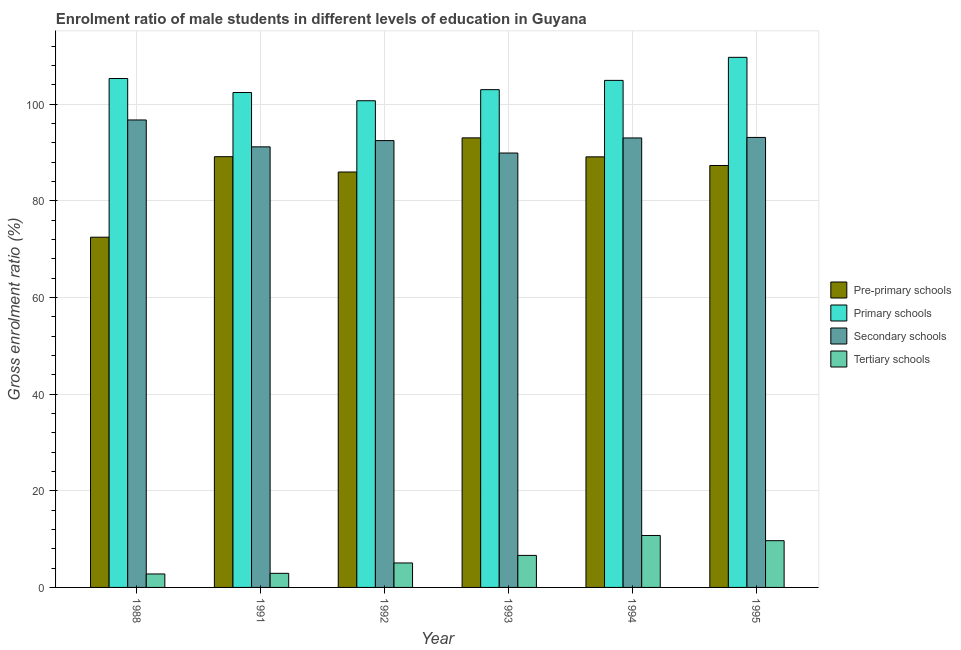How many different coloured bars are there?
Your answer should be compact. 4. How many groups of bars are there?
Offer a very short reply. 6. Are the number of bars on each tick of the X-axis equal?
Your answer should be very brief. Yes. How many bars are there on the 5th tick from the left?
Your answer should be compact. 4. What is the gross enrolment ratio(female) in primary schools in 1992?
Make the answer very short. 100.68. Across all years, what is the maximum gross enrolment ratio(female) in tertiary schools?
Provide a succinct answer. 10.75. Across all years, what is the minimum gross enrolment ratio(female) in primary schools?
Provide a succinct answer. 100.68. In which year was the gross enrolment ratio(female) in secondary schools maximum?
Make the answer very short. 1988. What is the total gross enrolment ratio(female) in primary schools in the graph?
Offer a terse response. 625.89. What is the difference between the gross enrolment ratio(female) in tertiary schools in 1991 and that in 1993?
Give a very brief answer. -3.71. What is the difference between the gross enrolment ratio(female) in primary schools in 1994 and the gross enrolment ratio(female) in pre-primary schools in 1988?
Offer a terse response. -0.39. What is the average gross enrolment ratio(female) in primary schools per year?
Offer a terse response. 104.32. In the year 1991, what is the difference between the gross enrolment ratio(female) in primary schools and gross enrolment ratio(female) in tertiary schools?
Provide a short and direct response. 0. In how many years, is the gross enrolment ratio(female) in primary schools greater than 36 %?
Your answer should be very brief. 6. What is the ratio of the gross enrolment ratio(female) in pre-primary schools in 1988 to that in 1993?
Ensure brevity in your answer.  0.78. Is the gross enrolment ratio(female) in tertiary schools in 1988 less than that in 1991?
Your answer should be very brief. Yes. Is the difference between the gross enrolment ratio(female) in primary schools in 1988 and 1991 greater than the difference between the gross enrolment ratio(female) in tertiary schools in 1988 and 1991?
Make the answer very short. No. What is the difference between the highest and the second highest gross enrolment ratio(female) in pre-primary schools?
Offer a terse response. 3.89. What is the difference between the highest and the lowest gross enrolment ratio(female) in tertiary schools?
Provide a succinct answer. 7.96. What does the 3rd bar from the left in 1991 represents?
Give a very brief answer. Secondary schools. What does the 2nd bar from the right in 1993 represents?
Offer a terse response. Secondary schools. Is it the case that in every year, the sum of the gross enrolment ratio(female) in pre-primary schools and gross enrolment ratio(female) in primary schools is greater than the gross enrolment ratio(female) in secondary schools?
Provide a short and direct response. Yes. Are all the bars in the graph horizontal?
Give a very brief answer. No. Does the graph contain any zero values?
Offer a very short reply. No. Where does the legend appear in the graph?
Your response must be concise. Center right. What is the title of the graph?
Make the answer very short. Enrolment ratio of male students in different levels of education in Guyana. Does "Tracking ability" appear as one of the legend labels in the graph?
Offer a terse response. No. What is the Gross enrolment ratio (%) of Pre-primary schools in 1988?
Your answer should be very brief. 72.46. What is the Gross enrolment ratio (%) of Primary schools in 1988?
Your answer should be compact. 105.28. What is the Gross enrolment ratio (%) of Secondary schools in 1988?
Provide a short and direct response. 96.71. What is the Gross enrolment ratio (%) of Tertiary schools in 1988?
Your answer should be very brief. 2.79. What is the Gross enrolment ratio (%) in Pre-primary schools in 1991?
Make the answer very short. 89.11. What is the Gross enrolment ratio (%) in Primary schools in 1991?
Keep it short and to the point. 102.39. What is the Gross enrolment ratio (%) of Secondary schools in 1991?
Give a very brief answer. 91.15. What is the Gross enrolment ratio (%) in Tertiary schools in 1991?
Offer a very short reply. 2.91. What is the Gross enrolment ratio (%) in Pre-primary schools in 1992?
Your answer should be very brief. 85.94. What is the Gross enrolment ratio (%) of Primary schools in 1992?
Ensure brevity in your answer.  100.68. What is the Gross enrolment ratio (%) in Secondary schools in 1992?
Offer a very short reply. 92.44. What is the Gross enrolment ratio (%) of Tertiary schools in 1992?
Ensure brevity in your answer.  5.06. What is the Gross enrolment ratio (%) of Pre-primary schools in 1993?
Provide a short and direct response. 93. What is the Gross enrolment ratio (%) in Primary schools in 1993?
Give a very brief answer. 102.97. What is the Gross enrolment ratio (%) in Secondary schools in 1993?
Your answer should be very brief. 89.87. What is the Gross enrolment ratio (%) of Tertiary schools in 1993?
Offer a terse response. 6.63. What is the Gross enrolment ratio (%) of Pre-primary schools in 1994?
Offer a terse response. 89.08. What is the Gross enrolment ratio (%) in Primary schools in 1994?
Your answer should be compact. 104.9. What is the Gross enrolment ratio (%) in Secondary schools in 1994?
Keep it short and to the point. 92.99. What is the Gross enrolment ratio (%) in Tertiary schools in 1994?
Your answer should be compact. 10.75. What is the Gross enrolment ratio (%) of Pre-primary schools in 1995?
Your response must be concise. 87.29. What is the Gross enrolment ratio (%) in Primary schools in 1995?
Your answer should be very brief. 109.66. What is the Gross enrolment ratio (%) in Secondary schools in 1995?
Your response must be concise. 93.09. What is the Gross enrolment ratio (%) in Tertiary schools in 1995?
Provide a short and direct response. 9.67. Across all years, what is the maximum Gross enrolment ratio (%) of Pre-primary schools?
Your answer should be compact. 93. Across all years, what is the maximum Gross enrolment ratio (%) in Primary schools?
Make the answer very short. 109.66. Across all years, what is the maximum Gross enrolment ratio (%) of Secondary schools?
Provide a short and direct response. 96.71. Across all years, what is the maximum Gross enrolment ratio (%) in Tertiary schools?
Give a very brief answer. 10.75. Across all years, what is the minimum Gross enrolment ratio (%) of Pre-primary schools?
Provide a short and direct response. 72.46. Across all years, what is the minimum Gross enrolment ratio (%) of Primary schools?
Provide a short and direct response. 100.68. Across all years, what is the minimum Gross enrolment ratio (%) in Secondary schools?
Offer a very short reply. 89.87. Across all years, what is the minimum Gross enrolment ratio (%) of Tertiary schools?
Keep it short and to the point. 2.79. What is the total Gross enrolment ratio (%) in Pre-primary schools in the graph?
Provide a succinct answer. 516.87. What is the total Gross enrolment ratio (%) of Primary schools in the graph?
Offer a terse response. 625.89. What is the total Gross enrolment ratio (%) of Secondary schools in the graph?
Offer a terse response. 556.24. What is the total Gross enrolment ratio (%) in Tertiary schools in the graph?
Offer a very short reply. 37.8. What is the difference between the Gross enrolment ratio (%) in Pre-primary schools in 1988 and that in 1991?
Your response must be concise. -16.65. What is the difference between the Gross enrolment ratio (%) in Primary schools in 1988 and that in 1991?
Your answer should be very brief. 2.89. What is the difference between the Gross enrolment ratio (%) in Secondary schools in 1988 and that in 1991?
Ensure brevity in your answer.  5.56. What is the difference between the Gross enrolment ratio (%) in Tertiary schools in 1988 and that in 1991?
Your answer should be very brief. -0.13. What is the difference between the Gross enrolment ratio (%) of Pre-primary schools in 1988 and that in 1992?
Provide a succinct answer. -13.48. What is the difference between the Gross enrolment ratio (%) in Primary schools in 1988 and that in 1992?
Give a very brief answer. 4.6. What is the difference between the Gross enrolment ratio (%) of Secondary schools in 1988 and that in 1992?
Offer a terse response. 4.27. What is the difference between the Gross enrolment ratio (%) in Tertiary schools in 1988 and that in 1992?
Your answer should be compact. -2.28. What is the difference between the Gross enrolment ratio (%) of Pre-primary schools in 1988 and that in 1993?
Offer a terse response. -20.55. What is the difference between the Gross enrolment ratio (%) of Primary schools in 1988 and that in 1993?
Your response must be concise. 2.31. What is the difference between the Gross enrolment ratio (%) in Secondary schools in 1988 and that in 1993?
Provide a short and direct response. 6.84. What is the difference between the Gross enrolment ratio (%) in Tertiary schools in 1988 and that in 1993?
Provide a succinct answer. -3.84. What is the difference between the Gross enrolment ratio (%) of Pre-primary schools in 1988 and that in 1994?
Your answer should be compact. -16.62. What is the difference between the Gross enrolment ratio (%) in Primary schools in 1988 and that in 1994?
Ensure brevity in your answer.  0.39. What is the difference between the Gross enrolment ratio (%) of Secondary schools in 1988 and that in 1994?
Give a very brief answer. 3.72. What is the difference between the Gross enrolment ratio (%) of Tertiary schools in 1988 and that in 1994?
Your response must be concise. -7.96. What is the difference between the Gross enrolment ratio (%) of Pre-primary schools in 1988 and that in 1995?
Make the answer very short. -14.83. What is the difference between the Gross enrolment ratio (%) in Primary schools in 1988 and that in 1995?
Make the answer very short. -4.38. What is the difference between the Gross enrolment ratio (%) in Secondary schools in 1988 and that in 1995?
Your response must be concise. 3.62. What is the difference between the Gross enrolment ratio (%) in Tertiary schools in 1988 and that in 1995?
Offer a terse response. -6.89. What is the difference between the Gross enrolment ratio (%) in Pre-primary schools in 1991 and that in 1992?
Give a very brief answer. 3.17. What is the difference between the Gross enrolment ratio (%) of Primary schools in 1991 and that in 1992?
Offer a terse response. 1.71. What is the difference between the Gross enrolment ratio (%) of Secondary schools in 1991 and that in 1992?
Your answer should be compact. -1.29. What is the difference between the Gross enrolment ratio (%) of Tertiary schools in 1991 and that in 1992?
Ensure brevity in your answer.  -2.15. What is the difference between the Gross enrolment ratio (%) in Pre-primary schools in 1991 and that in 1993?
Offer a very short reply. -3.89. What is the difference between the Gross enrolment ratio (%) in Primary schools in 1991 and that in 1993?
Your answer should be very brief. -0.58. What is the difference between the Gross enrolment ratio (%) in Secondary schools in 1991 and that in 1993?
Offer a terse response. 1.28. What is the difference between the Gross enrolment ratio (%) of Tertiary schools in 1991 and that in 1993?
Keep it short and to the point. -3.71. What is the difference between the Gross enrolment ratio (%) in Pre-primary schools in 1991 and that in 1994?
Your answer should be compact. 0.03. What is the difference between the Gross enrolment ratio (%) of Primary schools in 1991 and that in 1994?
Offer a terse response. -2.51. What is the difference between the Gross enrolment ratio (%) in Secondary schools in 1991 and that in 1994?
Provide a succinct answer. -1.84. What is the difference between the Gross enrolment ratio (%) in Tertiary schools in 1991 and that in 1994?
Provide a succinct answer. -7.83. What is the difference between the Gross enrolment ratio (%) in Pre-primary schools in 1991 and that in 1995?
Give a very brief answer. 1.82. What is the difference between the Gross enrolment ratio (%) of Primary schools in 1991 and that in 1995?
Offer a terse response. -7.28. What is the difference between the Gross enrolment ratio (%) of Secondary schools in 1991 and that in 1995?
Offer a terse response. -1.95. What is the difference between the Gross enrolment ratio (%) in Tertiary schools in 1991 and that in 1995?
Keep it short and to the point. -6.76. What is the difference between the Gross enrolment ratio (%) of Pre-primary schools in 1992 and that in 1993?
Your response must be concise. -7.07. What is the difference between the Gross enrolment ratio (%) in Primary schools in 1992 and that in 1993?
Provide a short and direct response. -2.29. What is the difference between the Gross enrolment ratio (%) in Secondary schools in 1992 and that in 1993?
Your answer should be very brief. 2.57. What is the difference between the Gross enrolment ratio (%) in Tertiary schools in 1992 and that in 1993?
Your response must be concise. -1.56. What is the difference between the Gross enrolment ratio (%) of Pre-primary schools in 1992 and that in 1994?
Your answer should be very brief. -3.14. What is the difference between the Gross enrolment ratio (%) in Primary schools in 1992 and that in 1994?
Ensure brevity in your answer.  -4.21. What is the difference between the Gross enrolment ratio (%) in Secondary schools in 1992 and that in 1994?
Your answer should be very brief. -0.55. What is the difference between the Gross enrolment ratio (%) of Tertiary schools in 1992 and that in 1994?
Your response must be concise. -5.69. What is the difference between the Gross enrolment ratio (%) in Pre-primary schools in 1992 and that in 1995?
Give a very brief answer. -1.35. What is the difference between the Gross enrolment ratio (%) in Primary schools in 1992 and that in 1995?
Your answer should be compact. -8.98. What is the difference between the Gross enrolment ratio (%) of Secondary schools in 1992 and that in 1995?
Offer a very short reply. -0.65. What is the difference between the Gross enrolment ratio (%) of Tertiary schools in 1992 and that in 1995?
Your answer should be compact. -4.61. What is the difference between the Gross enrolment ratio (%) in Pre-primary schools in 1993 and that in 1994?
Your response must be concise. 3.93. What is the difference between the Gross enrolment ratio (%) of Primary schools in 1993 and that in 1994?
Make the answer very short. -1.92. What is the difference between the Gross enrolment ratio (%) in Secondary schools in 1993 and that in 1994?
Make the answer very short. -3.12. What is the difference between the Gross enrolment ratio (%) of Tertiary schools in 1993 and that in 1994?
Keep it short and to the point. -4.12. What is the difference between the Gross enrolment ratio (%) in Pre-primary schools in 1993 and that in 1995?
Make the answer very short. 5.72. What is the difference between the Gross enrolment ratio (%) in Primary schools in 1993 and that in 1995?
Offer a very short reply. -6.69. What is the difference between the Gross enrolment ratio (%) in Secondary schools in 1993 and that in 1995?
Your answer should be compact. -3.22. What is the difference between the Gross enrolment ratio (%) in Tertiary schools in 1993 and that in 1995?
Keep it short and to the point. -3.04. What is the difference between the Gross enrolment ratio (%) in Pre-primary schools in 1994 and that in 1995?
Ensure brevity in your answer.  1.79. What is the difference between the Gross enrolment ratio (%) in Primary schools in 1994 and that in 1995?
Provide a succinct answer. -4.77. What is the difference between the Gross enrolment ratio (%) of Secondary schools in 1994 and that in 1995?
Offer a terse response. -0.11. What is the difference between the Gross enrolment ratio (%) in Tertiary schools in 1994 and that in 1995?
Provide a succinct answer. 1.08. What is the difference between the Gross enrolment ratio (%) in Pre-primary schools in 1988 and the Gross enrolment ratio (%) in Primary schools in 1991?
Ensure brevity in your answer.  -29.93. What is the difference between the Gross enrolment ratio (%) in Pre-primary schools in 1988 and the Gross enrolment ratio (%) in Secondary schools in 1991?
Give a very brief answer. -18.69. What is the difference between the Gross enrolment ratio (%) in Pre-primary schools in 1988 and the Gross enrolment ratio (%) in Tertiary schools in 1991?
Offer a terse response. 69.54. What is the difference between the Gross enrolment ratio (%) in Primary schools in 1988 and the Gross enrolment ratio (%) in Secondary schools in 1991?
Offer a very short reply. 14.14. What is the difference between the Gross enrolment ratio (%) in Primary schools in 1988 and the Gross enrolment ratio (%) in Tertiary schools in 1991?
Keep it short and to the point. 102.37. What is the difference between the Gross enrolment ratio (%) in Secondary schools in 1988 and the Gross enrolment ratio (%) in Tertiary schools in 1991?
Your answer should be very brief. 93.8. What is the difference between the Gross enrolment ratio (%) in Pre-primary schools in 1988 and the Gross enrolment ratio (%) in Primary schools in 1992?
Make the answer very short. -28.23. What is the difference between the Gross enrolment ratio (%) in Pre-primary schools in 1988 and the Gross enrolment ratio (%) in Secondary schools in 1992?
Keep it short and to the point. -19.98. What is the difference between the Gross enrolment ratio (%) of Pre-primary schools in 1988 and the Gross enrolment ratio (%) of Tertiary schools in 1992?
Your response must be concise. 67.4. What is the difference between the Gross enrolment ratio (%) of Primary schools in 1988 and the Gross enrolment ratio (%) of Secondary schools in 1992?
Offer a very short reply. 12.84. What is the difference between the Gross enrolment ratio (%) in Primary schools in 1988 and the Gross enrolment ratio (%) in Tertiary schools in 1992?
Keep it short and to the point. 100.22. What is the difference between the Gross enrolment ratio (%) in Secondary schools in 1988 and the Gross enrolment ratio (%) in Tertiary schools in 1992?
Give a very brief answer. 91.65. What is the difference between the Gross enrolment ratio (%) of Pre-primary schools in 1988 and the Gross enrolment ratio (%) of Primary schools in 1993?
Provide a short and direct response. -30.52. What is the difference between the Gross enrolment ratio (%) of Pre-primary schools in 1988 and the Gross enrolment ratio (%) of Secondary schools in 1993?
Your answer should be compact. -17.41. What is the difference between the Gross enrolment ratio (%) of Pre-primary schools in 1988 and the Gross enrolment ratio (%) of Tertiary schools in 1993?
Offer a terse response. 65.83. What is the difference between the Gross enrolment ratio (%) of Primary schools in 1988 and the Gross enrolment ratio (%) of Secondary schools in 1993?
Your response must be concise. 15.42. What is the difference between the Gross enrolment ratio (%) of Primary schools in 1988 and the Gross enrolment ratio (%) of Tertiary schools in 1993?
Your response must be concise. 98.66. What is the difference between the Gross enrolment ratio (%) in Secondary schools in 1988 and the Gross enrolment ratio (%) in Tertiary schools in 1993?
Your answer should be very brief. 90.08. What is the difference between the Gross enrolment ratio (%) of Pre-primary schools in 1988 and the Gross enrolment ratio (%) of Primary schools in 1994?
Ensure brevity in your answer.  -32.44. What is the difference between the Gross enrolment ratio (%) in Pre-primary schools in 1988 and the Gross enrolment ratio (%) in Secondary schools in 1994?
Ensure brevity in your answer.  -20.53. What is the difference between the Gross enrolment ratio (%) in Pre-primary schools in 1988 and the Gross enrolment ratio (%) in Tertiary schools in 1994?
Your answer should be compact. 61.71. What is the difference between the Gross enrolment ratio (%) in Primary schools in 1988 and the Gross enrolment ratio (%) in Secondary schools in 1994?
Keep it short and to the point. 12.3. What is the difference between the Gross enrolment ratio (%) of Primary schools in 1988 and the Gross enrolment ratio (%) of Tertiary schools in 1994?
Offer a very short reply. 94.54. What is the difference between the Gross enrolment ratio (%) in Secondary schools in 1988 and the Gross enrolment ratio (%) in Tertiary schools in 1994?
Offer a terse response. 85.96. What is the difference between the Gross enrolment ratio (%) in Pre-primary schools in 1988 and the Gross enrolment ratio (%) in Primary schools in 1995?
Offer a terse response. -37.21. What is the difference between the Gross enrolment ratio (%) in Pre-primary schools in 1988 and the Gross enrolment ratio (%) in Secondary schools in 1995?
Offer a very short reply. -20.64. What is the difference between the Gross enrolment ratio (%) of Pre-primary schools in 1988 and the Gross enrolment ratio (%) of Tertiary schools in 1995?
Your answer should be compact. 62.79. What is the difference between the Gross enrolment ratio (%) in Primary schools in 1988 and the Gross enrolment ratio (%) in Secondary schools in 1995?
Your answer should be very brief. 12.19. What is the difference between the Gross enrolment ratio (%) in Primary schools in 1988 and the Gross enrolment ratio (%) in Tertiary schools in 1995?
Make the answer very short. 95.61. What is the difference between the Gross enrolment ratio (%) in Secondary schools in 1988 and the Gross enrolment ratio (%) in Tertiary schools in 1995?
Your answer should be compact. 87.04. What is the difference between the Gross enrolment ratio (%) in Pre-primary schools in 1991 and the Gross enrolment ratio (%) in Primary schools in 1992?
Give a very brief answer. -11.57. What is the difference between the Gross enrolment ratio (%) in Pre-primary schools in 1991 and the Gross enrolment ratio (%) in Secondary schools in 1992?
Ensure brevity in your answer.  -3.33. What is the difference between the Gross enrolment ratio (%) of Pre-primary schools in 1991 and the Gross enrolment ratio (%) of Tertiary schools in 1992?
Keep it short and to the point. 84.05. What is the difference between the Gross enrolment ratio (%) of Primary schools in 1991 and the Gross enrolment ratio (%) of Secondary schools in 1992?
Offer a very short reply. 9.95. What is the difference between the Gross enrolment ratio (%) in Primary schools in 1991 and the Gross enrolment ratio (%) in Tertiary schools in 1992?
Your response must be concise. 97.33. What is the difference between the Gross enrolment ratio (%) in Secondary schools in 1991 and the Gross enrolment ratio (%) in Tertiary schools in 1992?
Your answer should be compact. 86.08. What is the difference between the Gross enrolment ratio (%) of Pre-primary schools in 1991 and the Gross enrolment ratio (%) of Primary schools in 1993?
Your response must be concise. -13.86. What is the difference between the Gross enrolment ratio (%) in Pre-primary schools in 1991 and the Gross enrolment ratio (%) in Secondary schools in 1993?
Offer a terse response. -0.76. What is the difference between the Gross enrolment ratio (%) of Pre-primary schools in 1991 and the Gross enrolment ratio (%) of Tertiary schools in 1993?
Offer a terse response. 82.48. What is the difference between the Gross enrolment ratio (%) in Primary schools in 1991 and the Gross enrolment ratio (%) in Secondary schools in 1993?
Your answer should be very brief. 12.52. What is the difference between the Gross enrolment ratio (%) in Primary schools in 1991 and the Gross enrolment ratio (%) in Tertiary schools in 1993?
Your answer should be very brief. 95.76. What is the difference between the Gross enrolment ratio (%) in Secondary schools in 1991 and the Gross enrolment ratio (%) in Tertiary schools in 1993?
Your response must be concise. 84.52. What is the difference between the Gross enrolment ratio (%) of Pre-primary schools in 1991 and the Gross enrolment ratio (%) of Primary schools in 1994?
Keep it short and to the point. -15.79. What is the difference between the Gross enrolment ratio (%) in Pre-primary schools in 1991 and the Gross enrolment ratio (%) in Secondary schools in 1994?
Give a very brief answer. -3.88. What is the difference between the Gross enrolment ratio (%) in Pre-primary schools in 1991 and the Gross enrolment ratio (%) in Tertiary schools in 1994?
Your response must be concise. 78.36. What is the difference between the Gross enrolment ratio (%) in Primary schools in 1991 and the Gross enrolment ratio (%) in Secondary schools in 1994?
Give a very brief answer. 9.4. What is the difference between the Gross enrolment ratio (%) of Primary schools in 1991 and the Gross enrolment ratio (%) of Tertiary schools in 1994?
Your answer should be very brief. 91.64. What is the difference between the Gross enrolment ratio (%) of Secondary schools in 1991 and the Gross enrolment ratio (%) of Tertiary schools in 1994?
Your answer should be compact. 80.4. What is the difference between the Gross enrolment ratio (%) of Pre-primary schools in 1991 and the Gross enrolment ratio (%) of Primary schools in 1995?
Your response must be concise. -20.56. What is the difference between the Gross enrolment ratio (%) in Pre-primary schools in 1991 and the Gross enrolment ratio (%) in Secondary schools in 1995?
Your response must be concise. -3.98. What is the difference between the Gross enrolment ratio (%) of Pre-primary schools in 1991 and the Gross enrolment ratio (%) of Tertiary schools in 1995?
Your response must be concise. 79.44. What is the difference between the Gross enrolment ratio (%) of Primary schools in 1991 and the Gross enrolment ratio (%) of Secondary schools in 1995?
Offer a terse response. 9.3. What is the difference between the Gross enrolment ratio (%) of Primary schools in 1991 and the Gross enrolment ratio (%) of Tertiary schools in 1995?
Your answer should be very brief. 92.72. What is the difference between the Gross enrolment ratio (%) of Secondary schools in 1991 and the Gross enrolment ratio (%) of Tertiary schools in 1995?
Offer a very short reply. 81.48. What is the difference between the Gross enrolment ratio (%) in Pre-primary schools in 1992 and the Gross enrolment ratio (%) in Primary schools in 1993?
Offer a very short reply. -17.04. What is the difference between the Gross enrolment ratio (%) in Pre-primary schools in 1992 and the Gross enrolment ratio (%) in Secondary schools in 1993?
Provide a short and direct response. -3.93. What is the difference between the Gross enrolment ratio (%) of Pre-primary schools in 1992 and the Gross enrolment ratio (%) of Tertiary schools in 1993?
Provide a succinct answer. 79.31. What is the difference between the Gross enrolment ratio (%) of Primary schools in 1992 and the Gross enrolment ratio (%) of Secondary schools in 1993?
Ensure brevity in your answer.  10.82. What is the difference between the Gross enrolment ratio (%) of Primary schools in 1992 and the Gross enrolment ratio (%) of Tertiary schools in 1993?
Your response must be concise. 94.06. What is the difference between the Gross enrolment ratio (%) in Secondary schools in 1992 and the Gross enrolment ratio (%) in Tertiary schools in 1993?
Your response must be concise. 85.81. What is the difference between the Gross enrolment ratio (%) of Pre-primary schools in 1992 and the Gross enrolment ratio (%) of Primary schools in 1994?
Offer a very short reply. -18.96. What is the difference between the Gross enrolment ratio (%) in Pre-primary schools in 1992 and the Gross enrolment ratio (%) in Secondary schools in 1994?
Provide a succinct answer. -7.05. What is the difference between the Gross enrolment ratio (%) in Pre-primary schools in 1992 and the Gross enrolment ratio (%) in Tertiary schools in 1994?
Your response must be concise. 75.19. What is the difference between the Gross enrolment ratio (%) of Primary schools in 1992 and the Gross enrolment ratio (%) of Secondary schools in 1994?
Your answer should be very brief. 7.7. What is the difference between the Gross enrolment ratio (%) in Primary schools in 1992 and the Gross enrolment ratio (%) in Tertiary schools in 1994?
Your answer should be compact. 89.94. What is the difference between the Gross enrolment ratio (%) in Secondary schools in 1992 and the Gross enrolment ratio (%) in Tertiary schools in 1994?
Provide a short and direct response. 81.69. What is the difference between the Gross enrolment ratio (%) of Pre-primary schools in 1992 and the Gross enrolment ratio (%) of Primary schools in 1995?
Make the answer very short. -23.73. What is the difference between the Gross enrolment ratio (%) in Pre-primary schools in 1992 and the Gross enrolment ratio (%) in Secondary schools in 1995?
Provide a short and direct response. -7.15. What is the difference between the Gross enrolment ratio (%) in Pre-primary schools in 1992 and the Gross enrolment ratio (%) in Tertiary schools in 1995?
Your answer should be compact. 76.27. What is the difference between the Gross enrolment ratio (%) of Primary schools in 1992 and the Gross enrolment ratio (%) of Secondary schools in 1995?
Provide a short and direct response. 7.59. What is the difference between the Gross enrolment ratio (%) in Primary schools in 1992 and the Gross enrolment ratio (%) in Tertiary schools in 1995?
Your response must be concise. 91.01. What is the difference between the Gross enrolment ratio (%) of Secondary schools in 1992 and the Gross enrolment ratio (%) of Tertiary schools in 1995?
Keep it short and to the point. 82.77. What is the difference between the Gross enrolment ratio (%) in Pre-primary schools in 1993 and the Gross enrolment ratio (%) in Primary schools in 1994?
Offer a very short reply. -11.89. What is the difference between the Gross enrolment ratio (%) of Pre-primary schools in 1993 and the Gross enrolment ratio (%) of Secondary schools in 1994?
Keep it short and to the point. 0.02. What is the difference between the Gross enrolment ratio (%) of Pre-primary schools in 1993 and the Gross enrolment ratio (%) of Tertiary schools in 1994?
Ensure brevity in your answer.  82.26. What is the difference between the Gross enrolment ratio (%) in Primary schools in 1993 and the Gross enrolment ratio (%) in Secondary schools in 1994?
Offer a terse response. 9.99. What is the difference between the Gross enrolment ratio (%) in Primary schools in 1993 and the Gross enrolment ratio (%) in Tertiary schools in 1994?
Offer a very short reply. 92.23. What is the difference between the Gross enrolment ratio (%) of Secondary schools in 1993 and the Gross enrolment ratio (%) of Tertiary schools in 1994?
Your answer should be compact. 79.12. What is the difference between the Gross enrolment ratio (%) in Pre-primary schools in 1993 and the Gross enrolment ratio (%) in Primary schools in 1995?
Provide a succinct answer. -16.66. What is the difference between the Gross enrolment ratio (%) of Pre-primary schools in 1993 and the Gross enrolment ratio (%) of Secondary schools in 1995?
Provide a succinct answer. -0.09. What is the difference between the Gross enrolment ratio (%) of Pre-primary schools in 1993 and the Gross enrolment ratio (%) of Tertiary schools in 1995?
Offer a very short reply. 83.33. What is the difference between the Gross enrolment ratio (%) in Primary schools in 1993 and the Gross enrolment ratio (%) in Secondary schools in 1995?
Offer a very short reply. 9.88. What is the difference between the Gross enrolment ratio (%) of Primary schools in 1993 and the Gross enrolment ratio (%) of Tertiary schools in 1995?
Your answer should be compact. 93.3. What is the difference between the Gross enrolment ratio (%) of Secondary schools in 1993 and the Gross enrolment ratio (%) of Tertiary schools in 1995?
Provide a succinct answer. 80.2. What is the difference between the Gross enrolment ratio (%) in Pre-primary schools in 1994 and the Gross enrolment ratio (%) in Primary schools in 1995?
Keep it short and to the point. -20.59. What is the difference between the Gross enrolment ratio (%) of Pre-primary schools in 1994 and the Gross enrolment ratio (%) of Secondary schools in 1995?
Offer a very short reply. -4.02. What is the difference between the Gross enrolment ratio (%) in Pre-primary schools in 1994 and the Gross enrolment ratio (%) in Tertiary schools in 1995?
Provide a succinct answer. 79.41. What is the difference between the Gross enrolment ratio (%) of Primary schools in 1994 and the Gross enrolment ratio (%) of Secondary schools in 1995?
Offer a very short reply. 11.8. What is the difference between the Gross enrolment ratio (%) in Primary schools in 1994 and the Gross enrolment ratio (%) in Tertiary schools in 1995?
Provide a short and direct response. 95.23. What is the difference between the Gross enrolment ratio (%) of Secondary schools in 1994 and the Gross enrolment ratio (%) of Tertiary schools in 1995?
Make the answer very short. 83.32. What is the average Gross enrolment ratio (%) in Pre-primary schools per year?
Offer a terse response. 86.15. What is the average Gross enrolment ratio (%) in Primary schools per year?
Offer a terse response. 104.32. What is the average Gross enrolment ratio (%) of Secondary schools per year?
Offer a terse response. 92.71. What is the average Gross enrolment ratio (%) in Tertiary schools per year?
Make the answer very short. 6.3. In the year 1988, what is the difference between the Gross enrolment ratio (%) of Pre-primary schools and Gross enrolment ratio (%) of Primary schools?
Keep it short and to the point. -32.83. In the year 1988, what is the difference between the Gross enrolment ratio (%) of Pre-primary schools and Gross enrolment ratio (%) of Secondary schools?
Offer a very short reply. -24.25. In the year 1988, what is the difference between the Gross enrolment ratio (%) in Pre-primary schools and Gross enrolment ratio (%) in Tertiary schools?
Keep it short and to the point. 69.67. In the year 1988, what is the difference between the Gross enrolment ratio (%) in Primary schools and Gross enrolment ratio (%) in Secondary schools?
Offer a terse response. 8.57. In the year 1988, what is the difference between the Gross enrolment ratio (%) in Primary schools and Gross enrolment ratio (%) in Tertiary schools?
Ensure brevity in your answer.  102.5. In the year 1988, what is the difference between the Gross enrolment ratio (%) of Secondary schools and Gross enrolment ratio (%) of Tertiary schools?
Make the answer very short. 93.92. In the year 1991, what is the difference between the Gross enrolment ratio (%) of Pre-primary schools and Gross enrolment ratio (%) of Primary schools?
Give a very brief answer. -13.28. In the year 1991, what is the difference between the Gross enrolment ratio (%) in Pre-primary schools and Gross enrolment ratio (%) in Secondary schools?
Provide a short and direct response. -2.04. In the year 1991, what is the difference between the Gross enrolment ratio (%) of Pre-primary schools and Gross enrolment ratio (%) of Tertiary schools?
Provide a succinct answer. 86.2. In the year 1991, what is the difference between the Gross enrolment ratio (%) in Primary schools and Gross enrolment ratio (%) in Secondary schools?
Offer a terse response. 11.24. In the year 1991, what is the difference between the Gross enrolment ratio (%) in Primary schools and Gross enrolment ratio (%) in Tertiary schools?
Make the answer very short. 99.48. In the year 1991, what is the difference between the Gross enrolment ratio (%) in Secondary schools and Gross enrolment ratio (%) in Tertiary schools?
Give a very brief answer. 88.23. In the year 1992, what is the difference between the Gross enrolment ratio (%) in Pre-primary schools and Gross enrolment ratio (%) in Primary schools?
Your response must be concise. -14.74. In the year 1992, what is the difference between the Gross enrolment ratio (%) of Pre-primary schools and Gross enrolment ratio (%) of Secondary schools?
Ensure brevity in your answer.  -6.5. In the year 1992, what is the difference between the Gross enrolment ratio (%) of Pre-primary schools and Gross enrolment ratio (%) of Tertiary schools?
Provide a short and direct response. 80.88. In the year 1992, what is the difference between the Gross enrolment ratio (%) in Primary schools and Gross enrolment ratio (%) in Secondary schools?
Your answer should be compact. 8.25. In the year 1992, what is the difference between the Gross enrolment ratio (%) in Primary schools and Gross enrolment ratio (%) in Tertiary schools?
Keep it short and to the point. 95.62. In the year 1992, what is the difference between the Gross enrolment ratio (%) of Secondary schools and Gross enrolment ratio (%) of Tertiary schools?
Offer a very short reply. 87.38. In the year 1993, what is the difference between the Gross enrolment ratio (%) in Pre-primary schools and Gross enrolment ratio (%) in Primary schools?
Offer a terse response. -9.97. In the year 1993, what is the difference between the Gross enrolment ratio (%) in Pre-primary schools and Gross enrolment ratio (%) in Secondary schools?
Provide a short and direct response. 3.14. In the year 1993, what is the difference between the Gross enrolment ratio (%) in Pre-primary schools and Gross enrolment ratio (%) in Tertiary schools?
Provide a succinct answer. 86.38. In the year 1993, what is the difference between the Gross enrolment ratio (%) in Primary schools and Gross enrolment ratio (%) in Secondary schools?
Keep it short and to the point. 13.11. In the year 1993, what is the difference between the Gross enrolment ratio (%) in Primary schools and Gross enrolment ratio (%) in Tertiary schools?
Ensure brevity in your answer.  96.35. In the year 1993, what is the difference between the Gross enrolment ratio (%) in Secondary schools and Gross enrolment ratio (%) in Tertiary schools?
Make the answer very short. 83.24. In the year 1994, what is the difference between the Gross enrolment ratio (%) in Pre-primary schools and Gross enrolment ratio (%) in Primary schools?
Give a very brief answer. -15.82. In the year 1994, what is the difference between the Gross enrolment ratio (%) in Pre-primary schools and Gross enrolment ratio (%) in Secondary schools?
Ensure brevity in your answer.  -3.91. In the year 1994, what is the difference between the Gross enrolment ratio (%) in Pre-primary schools and Gross enrolment ratio (%) in Tertiary schools?
Your response must be concise. 78.33. In the year 1994, what is the difference between the Gross enrolment ratio (%) of Primary schools and Gross enrolment ratio (%) of Secondary schools?
Your answer should be compact. 11.91. In the year 1994, what is the difference between the Gross enrolment ratio (%) in Primary schools and Gross enrolment ratio (%) in Tertiary schools?
Keep it short and to the point. 94.15. In the year 1994, what is the difference between the Gross enrolment ratio (%) in Secondary schools and Gross enrolment ratio (%) in Tertiary schools?
Make the answer very short. 82.24. In the year 1995, what is the difference between the Gross enrolment ratio (%) of Pre-primary schools and Gross enrolment ratio (%) of Primary schools?
Your response must be concise. -22.38. In the year 1995, what is the difference between the Gross enrolment ratio (%) in Pre-primary schools and Gross enrolment ratio (%) in Secondary schools?
Offer a very short reply. -5.8. In the year 1995, what is the difference between the Gross enrolment ratio (%) in Pre-primary schools and Gross enrolment ratio (%) in Tertiary schools?
Offer a very short reply. 77.62. In the year 1995, what is the difference between the Gross enrolment ratio (%) in Primary schools and Gross enrolment ratio (%) in Secondary schools?
Offer a terse response. 16.57. In the year 1995, what is the difference between the Gross enrolment ratio (%) in Primary schools and Gross enrolment ratio (%) in Tertiary schools?
Provide a short and direct response. 99.99. In the year 1995, what is the difference between the Gross enrolment ratio (%) of Secondary schools and Gross enrolment ratio (%) of Tertiary schools?
Make the answer very short. 83.42. What is the ratio of the Gross enrolment ratio (%) of Pre-primary schools in 1988 to that in 1991?
Your answer should be compact. 0.81. What is the ratio of the Gross enrolment ratio (%) of Primary schools in 1988 to that in 1991?
Ensure brevity in your answer.  1.03. What is the ratio of the Gross enrolment ratio (%) in Secondary schools in 1988 to that in 1991?
Offer a very short reply. 1.06. What is the ratio of the Gross enrolment ratio (%) of Tertiary schools in 1988 to that in 1991?
Provide a succinct answer. 0.96. What is the ratio of the Gross enrolment ratio (%) in Pre-primary schools in 1988 to that in 1992?
Provide a short and direct response. 0.84. What is the ratio of the Gross enrolment ratio (%) in Primary schools in 1988 to that in 1992?
Provide a succinct answer. 1.05. What is the ratio of the Gross enrolment ratio (%) of Secondary schools in 1988 to that in 1992?
Keep it short and to the point. 1.05. What is the ratio of the Gross enrolment ratio (%) in Tertiary schools in 1988 to that in 1992?
Your answer should be very brief. 0.55. What is the ratio of the Gross enrolment ratio (%) of Pre-primary schools in 1988 to that in 1993?
Ensure brevity in your answer.  0.78. What is the ratio of the Gross enrolment ratio (%) in Primary schools in 1988 to that in 1993?
Ensure brevity in your answer.  1.02. What is the ratio of the Gross enrolment ratio (%) in Secondary schools in 1988 to that in 1993?
Provide a succinct answer. 1.08. What is the ratio of the Gross enrolment ratio (%) in Tertiary schools in 1988 to that in 1993?
Ensure brevity in your answer.  0.42. What is the ratio of the Gross enrolment ratio (%) of Pre-primary schools in 1988 to that in 1994?
Your answer should be compact. 0.81. What is the ratio of the Gross enrolment ratio (%) of Tertiary schools in 1988 to that in 1994?
Give a very brief answer. 0.26. What is the ratio of the Gross enrolment ratio (%) of Pre-primary schools in 1988 to that in 1995?
Keep it short and to the point. 0.83. What is the ratio of the Gross enrolment ratio (%) of Secondary schools in 1988 to that in 1995?
Offer a very short reply. 1.04. What is the ratio of the Gross enrolment ratio (%) of Tertiary schools in 1988 to that in 1995?
Offer a terse response. 0.29. What is the ratio of the Gross enrolment ratio (%) of Pre-primary schools in 1991 to that in 1992?
Ensure brevity in your answer.  1.04. What is the ratio of the Gross enrolment ratio (%) in Primary schools in 1991 to that in 1992?
Keep it short and to the point. 1.02. What is the ratio of the Gross enrolment ratio (%) of Secondary schools in 1991 to that in 1992?
Provide a succinct answer. 0.99. What is the ratio of the Gross enrolment ratio (%) in Tertiary schools in 1991 to that in 1992?
Your answer should be very brief. 0.58. What is the ratio of the Gross enrolment ratio (%) in Pre-primary schools in 1991 to that in 1993?
Your answer should be compact. 0.96. What is the ratio of the Gross enrolment ratio (%) of Primary schools in 1991 to that in 1993?
Make the answer very short. 0.99. What is the ratio of the Gross enrolment ratio (%) of Secondary schools in 1991 to that in 1993?
Your answer should be compact. 1.01. What is the ratio of the Gross enrolment ratio (%) in Tertiary schools in 1991 to that in 1993?
Make the answer very short. 0.44. What is the ratio of the Gross enrolment ratio (%) in Pre-primary schools in 1991 to that in 1994?
Offer a very short reply. 1. What is the ratio of the Gross enrolment ratio (%) of Primary schools in 1991 to that in 1994?
Offer a terse response. 0.98. What is the ratio of the Gross enrolment ratio (%) of Secondary schools in 1991 to that in 1994?
Your response must be concise. 0.98. What is the ratio of the Gross enrolment ratio (%) of Tertiary schools in 1991 to that in 1994?
Offer a very short reply. 0.27. What is the ratio of the Gross enrolment ratio (%) of Pre-primary schools in 1991 to that in 1995?
Give a very brief answer. 1.02. What is the ratio of the Gross enrolment ratio (%) in Primary schools in 1991 to that in 1995?
Provide a short and direct response. 0.93. What is the ratio of the Gross enrolment ratio (%) in Secondary schools in 1991 to that in 1995?
Provide a succinct answer. 0.98. What is the ratio of the Gross enrolment ratio (%) in Tertiary schools in 1991 to that in 1995?
Make the answer very short. 0.3. What is the ratio of the Gross enrolment ratio (%) of Pre-primary schools in 1992 to that in 1993?
Your response must be concise. 0.92. What is the ratio of the Gross enrolment ratio (%) in Primary schools in 1992 to that in 1993?
Provide a short and direct response. 0.98. What is the ratio of the Gross enrolment ratio (%) of Secondary schools in 1992 to that in 1993?
Provide a short and direct response. 1.03. What is the ratio of the Gross enrolment ratio (%) in Tertiary schools in 1992 to that in 1993?
Provide a succinct answer. 0.76. What is the ratio of the Gross enrolment ratio (%) in Pre-primary schools in 1992 to that in 1994?
Make the answer very short. 0.96. What is the ratio of the Gross enrolment ratio (%) in Primary schools in 1992 to that in 1994?
Your answer should be very brief. 0.96. What is the ratio of the Gross enrolment ratio (%) in Secondary schools in 1992 to that in 1994?
Offer a terse response. 0.99. What is the ratio of the Gross enrolment ratio (%) of Tertiary schools in 1992 to that in 1994?
Your response must be concise. 0.47. What is the ratio of the Gross enrolment ratio (%) of Pre-primary schools in 1992 to that in 1995?
Offer a very short reply. 0.98. What is the ratio of the Gross enrolment ratio (%) of Primary schools in 1992 to that in 1995?
Offer a very short reply. 0.92. What is the ratio of the Gross enrolment ratio (%) of Secondary schools in 1992 to that in 1995?
Your answer should be compact. 0.99. What is the ratio of the Gross enrolment ratio (%) in Tertiary schools in 1992 to that in 1995?
Ensure brevity in your answer.  0.52. What is the ratio of the Gross enrolment ratio (%) of Pre-primary schools in 1993 to that in 1994?
Give a very brief answer. 1.04. What is the ratio of the Gross enrolment ratio (%) in Primary schools in 1993 to that in 1994?
Provide a succinct answer. 0.98. What is the ratio of the Gross enrolment ratio (%) in Secondary schools in 1993 to that in 1994?
Your answer should be compact. 0.97. What is the ratio of the Gross enrolment ratio (%) in Tertiary schools in 1993 to that in 1994?
Ensure brevity in your answer.  0.62. What is the ratio of the Gross enrolment ratio (%) in Pre-primary schools in 1993 to that in 1995?
Offer a terse response. 1.07. What is the ratio of the Gross enrolment ratio (%) in Primary schools in 1993 to that in 1995?
Offer a terse response. 0.94. What is the ratio of the Gross enrolment ratio (%) in Secondary schools in 1993 to that in 1995?
Your answer should be compact. 0.97. What is the ratio of the Gross enrolment ratio (%) in Tertiary schools in 1993 to that in 1995?
Provide a succinct answer. 0.69. What is the ratio of the Gross enrolment ratio (%) in Pre-primary schools in 1994 to that in 1995?
Your response must be concise. 1.02. What is the ratio of the Gross enrolment ratio (%) of Primary schools in 1994 to that in 1995?
Offer a terse response. 0.96. What is the ratio of the Gross enrolment ratio (%) in Secondary schools in 1994 to that in 1995?
Offer a very short reply. 1. What is the ratio of the Gross enrolment ratio (%) in Tertiary schools in 1994 to that in 1995?
Ensure brevity in your answer.  1.11. What is the difference between the highest and the second highest Gross enrolment ratio (%) of Pre-primary schools?
Give a very brief answer. 3.89. What is the difference between the highest and the second highest Gross enrolment ratio (%) of Primary schools?
Make the answer very short. 4.38. What is the difference between the highest and the second highest Gross enrolment ratio (%) of Secondary schools?
Provide a succinct answer. 3.62. What is the difference between the highest and the second highest Gross enrolment ratio (%) of Tertiary schools?
Your answer should be very brief. 1.08. What is the difference between the highest and the lowest Gross enrolment ratio (%) of Pre-primary schools?
Offer a terse response. 20.55. What is the difference between the highest and the lowest Gross enrolment ratio (%) of Primary schools?
Make the answer very short. 8.98. What is the difference between the highest and the lowest Gross enrolment ratio (%) of Secondary schools?
Make the answer very short. 6.84. What is the difference between the highest and the lowest Gross enrolment ratio (%) of Tertiary schools?
Provide a short and direct response. 7.96. 